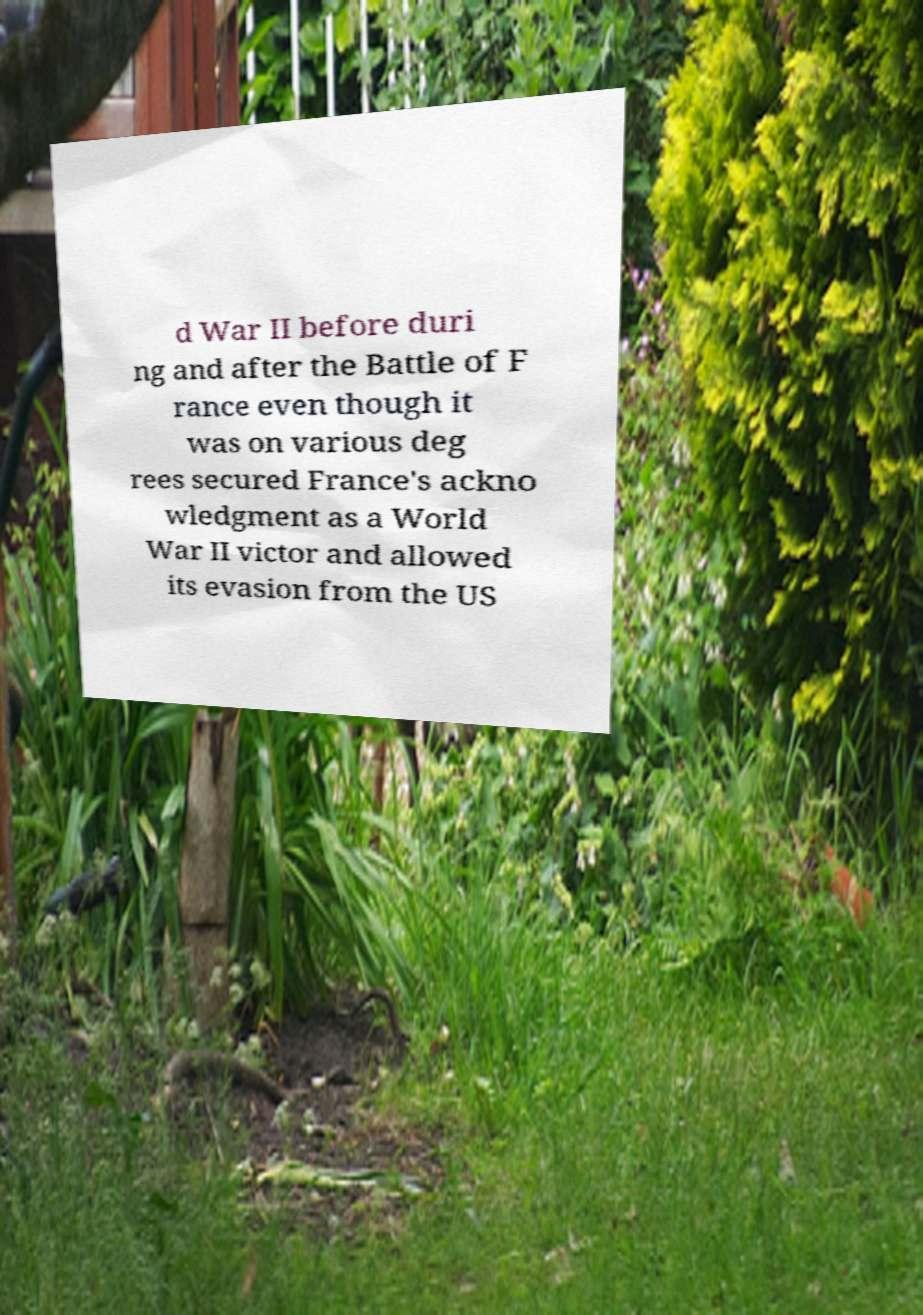Can you accurately transcribe the text from the provided image for me? d War II before duri ng and after the Battle of F rance even though it was on various deg rees secured France's ackno wledgment as a World War II victor and allowed its evasion from the US 